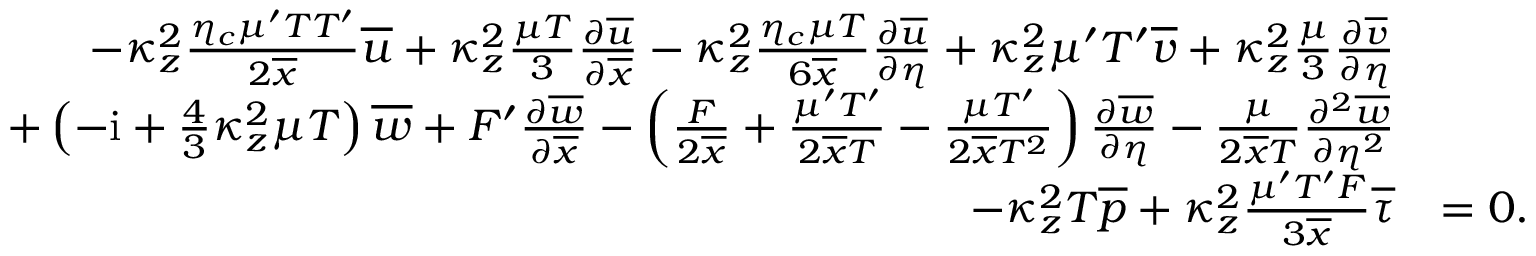<formula> <loc_0><loc_0><loc_500><loc_500>\begin{array} { r l } { - \kappa _ { z } ^ { 2 } \frac { \eta _ { c } \mu ^ { \prime } T T ^ { \prime } } { 2 \overline { x } } \overline { u } + \kappa _ { z } ^ { 2 } \frac { \mu T } { 3 } \frac { \partial \overline { u } } { \partial \overline { x } } - \kappa _ { z } ^ { 2 } \frac { \eta _ { c } \mu T } { 6 \overline { x } } \frac { \partial \overline { u } } { \partial \eta } + \kappa _ { z } ^ { 2 } \mu ^ { \prime } T ^ { \prime } \overline { v } + \kappa _ { z } ^ { 2 } \frac { \mu } { 3 } \frac { \partial \overline { v } } { \partial \eta } } \\ { + \left ( - i + \frac { 4 } { 3 } \kappa _ { z } ^ { 2 } \mu T \right ) \overline { w } + F ^ { \prime } \frac { \partial \overline { w } } { \partial \overline { x } } - \left ( \frac { F } { 2 \overline { x } } + \frac { \mu ^ { \prime } T ^ { \prime } } { 2 \overline { x } T } - \frac { \mu T ^ { \prime } } { 2 \overline { x } T ^ { 2 } } \right ) \frac { \partial \overline { w } } { \partial \eta } - \frac { \mu } { 2 \overline { x } T } \frac { \partial ^ { 2 } \overline { w } } { \partial \eta ^ { 2 } } } \\ { - \kappa _ { z } ^ { 2 } T \overline { p } + \kappa _ { z } ^ { 2 } \frac { \mu ^ { \prime } T ^ { \prime } F } { 3 \overline { x } } \overline { \tau } } & { = 0 . } \end{array}</formula> 